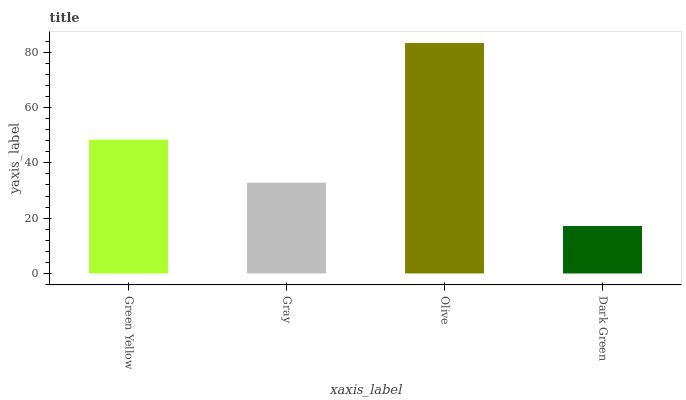Is Dark Green the minimum?
Answer yes or no. Yes. Is Olive the maximum?
Answer yes or no. Yes. Is Gray the minimum?
Answer yes or no. No. Is Gray the maximum?
Answer yes or no. No. Is Green Yellow greater than Gray?
Answer yes or no. Yes. Is Gray less than Green Yellow?
Answer yes or no. Yes. Is Gray greater than Green Yellow?
Answer yes or no. No. Is Green Yellow less than Gray?
Answer yes or no. No. Is Green Yellow the high median?
Answer yes or no. Yes. Is Gray the low median?
Answer yes or no. Yes. Is Dark Green the high median?
Answer yes or no. No. Is Dark Green the low median?
Answer yes or no. No. 